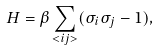<formula> <loc_0><loc_0><loc_500><loc_500>H = \beta \sum _ { < i j > } ( \sigma _ { i } \sigma _ { j } - 1 ) ,</formula> 